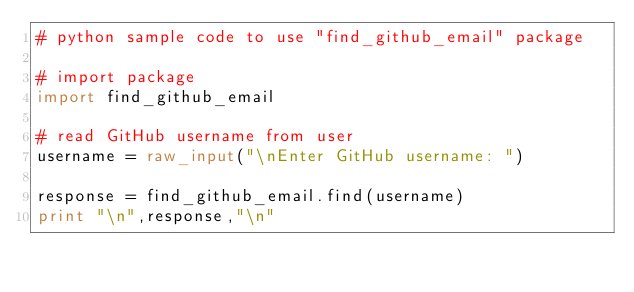<code> <loc_0><loc_0><loc_500><loc_500><_Python_># python sample code to use "find_github_email" package

# import package
import find_github_email

# read GitHub username from user
username = raw_input("\nEnter GitHub username: ")

response = find_github_email.find(username)
print "\n",response,"\n"
</code> 